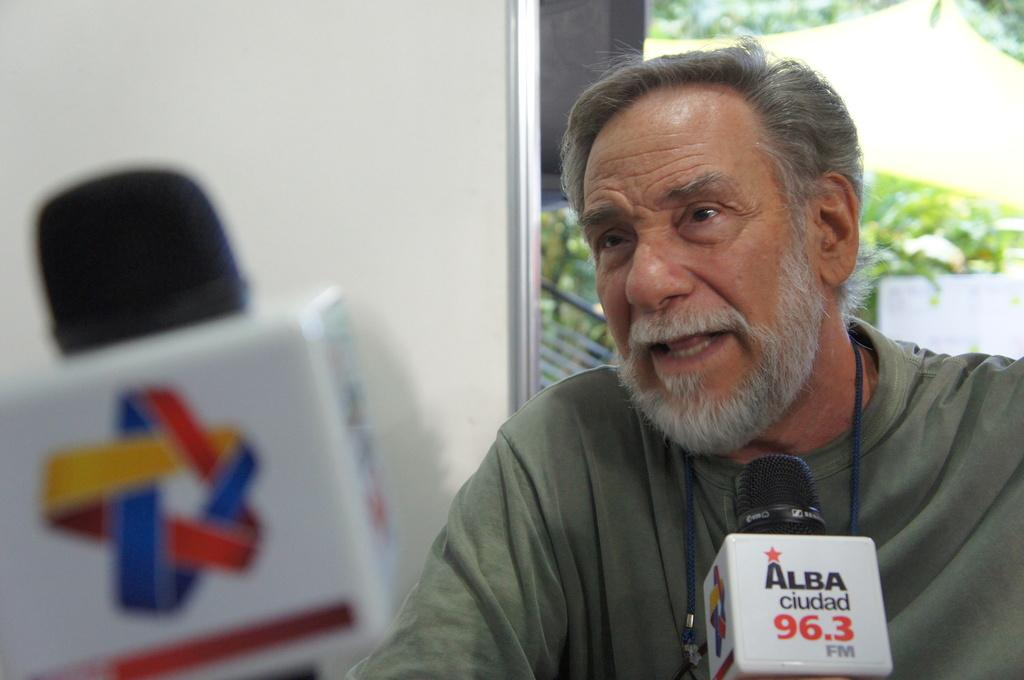What object is the man using in the image? There is a microphone in the image, and a man is talking into it. What might the man be doing with the microphone? The man is likely using the microphone to amplify his voice or record his speech. What can be seen in the background of the image? There is a board and trees visible in the background of the image. What type of cattle can be seen grazing near the coast in the image? There is no coast or cattle present in the image; it features a man talking into a microphone with a board and trees in the background. 